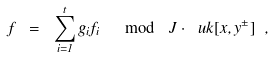Convert formula to latex. <formula><loc_0><loc_0><loc_500><loc_500>f \ = \ \sum _ { i = 1 } ^ { t } g _ { i } f _ { i } \ \mod \ J \cdot \ u k [ x , y ^ { \pm } ] \ ,</formula> 